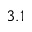<formula> <loc_0><loc_0><loc_500><loc_500>3 . 1</formula> 